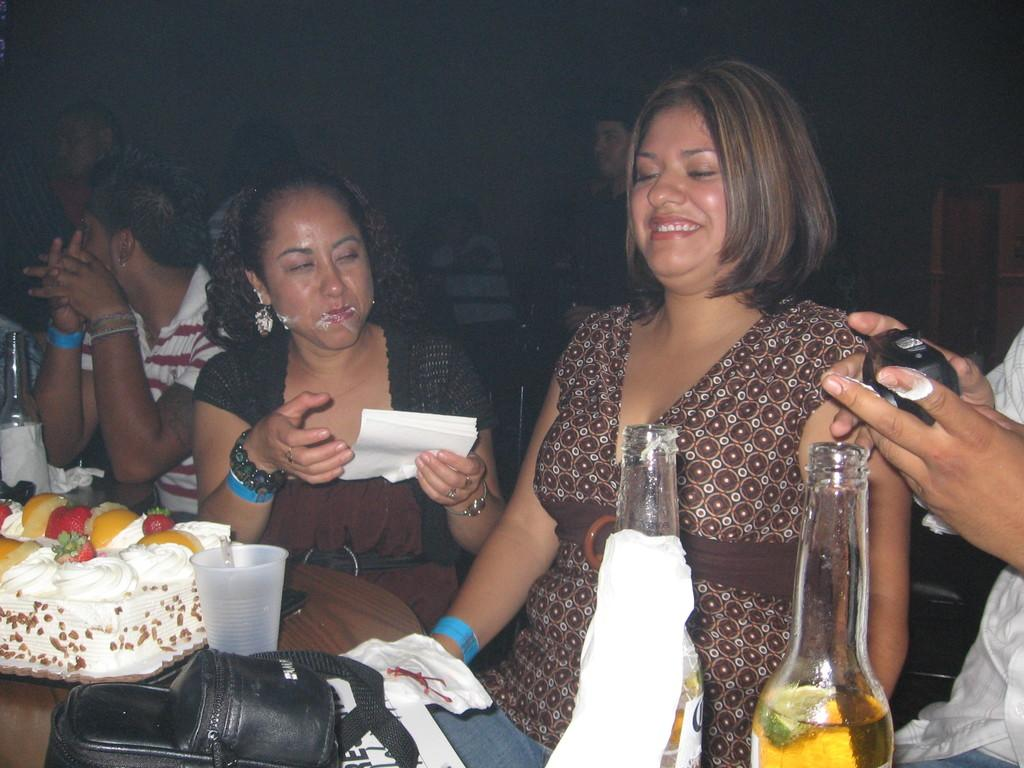What are the people in the image doing? There are persons sitting in the image, which suggests they might be resting or socializing. What is on the table in the image? There is a cake, fruits, a glass, a bag, cloth, and a bottle on the table. What might be used for cleaning or wiping in the image? A person is holding tissue in the image, which can be used for cleaning or wiping. What color is the crayon used to draw on the table in the image? There is no crayon present in the image, and therefore no such drawing or color can be observed. What time of day is it in the image, given the presence of the afternoon sun? The provided facts do not mention the time of day or the presence of the afternoon sun, so it cannot be determined from the image. 